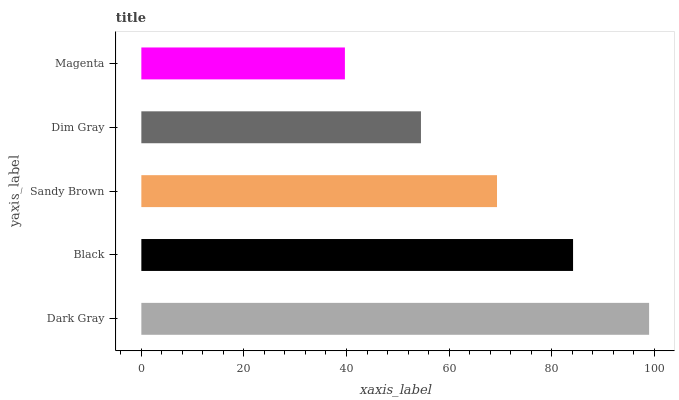Is Magenta the minimum?
Answer yes or no. Yes. Is Dark Gray the maximum?
Answer yes or no. Yes. Is Black the minimum?
Answer yes or no. No. Is Black the maximum?
Answer yes or no. No. Is Dark Gray greater than Black?
Answer yes or no. Yes. Is Black less than Dark Gray?
Answer yes or no. Yes. Is Black greater than Dark Gray?
Answer yes or no. No. Is Dark Gray less than Black?
Answer yes or no. No. Is Sandy Brown the high median?
Answer yes or no. Yes. Is Sandy Brown the low median?
Answer yes or no. Yes. Is Dark Gray the high median?
Answer yes or no. No. Is Magenta the low median?
Answer yes or no. No. 